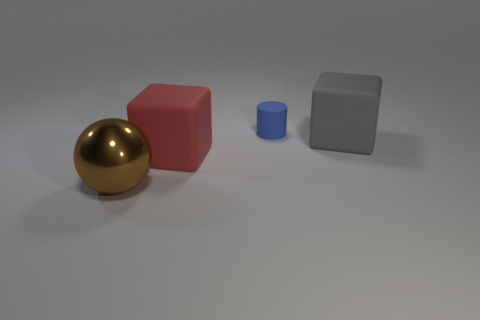Add 2 rubber objects. How many objects exist? 6 Subtract all cylinders. How many objects are left? 3 Subtract 0 blue blocks. How many objects are left? 4 Subtract all big brown spheres. Subtract all brown spheres. How many objects are left? 2 Add 1 blocks. How many blocks are left? 3 Add 1 big brown things. How many big brown things exist? 2 